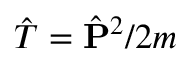<formula> <loc_0><loc_0><loc_500><loc_500>\hat { T } = \hat { P } ^ { 2 } / 2 m</formula> 